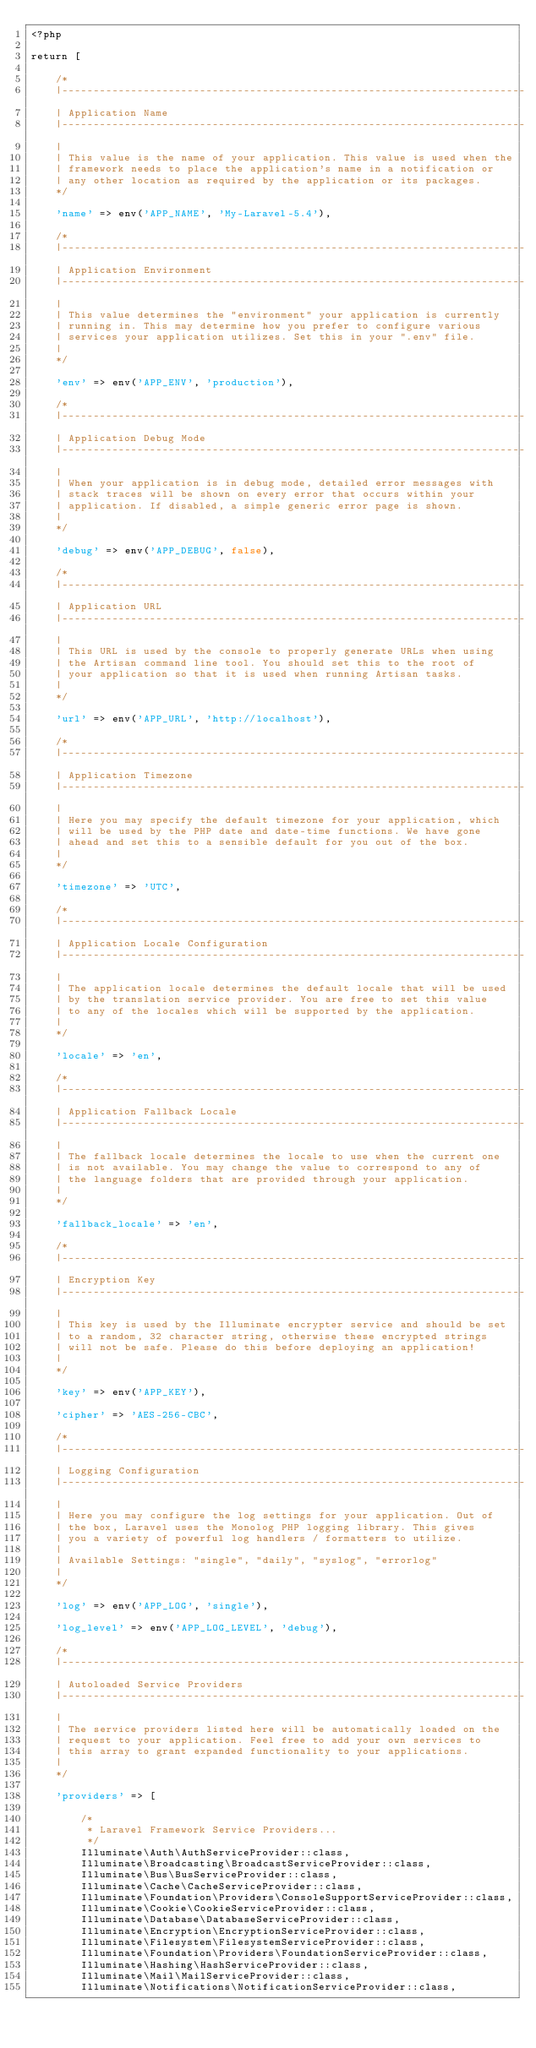Convert code to text. <code><loc_0><loc_0><loc_500><loc_500><_PHP_><?php

return [

    /*
    |--------------------------------------------------------------------------
    | Application Name
    |--------------------------------------------------------------------------
    |
    | This value is the name of your application. This value is used when the
    | framework needs to place the application's name in a notification or
    | any other location as required by the application or its packages.
    */

    'name' => env('APP_NAME', 'My-Laravel-5.4'),

    /*
    |--------------------------------------------------------------------------
    | Application Environment
    |--------------------------------------------------------------------------
    |
    | This value determines the "environment" your application is currently
    | running in. This may determine how you prefer to configure various
    | services your application utilizes. Set this in your ".env" file.
    |
    */

    'env' => env('APP_ENV', 'production'),

    /*
    |--------------------------------------------------------------------------
    | Application Debug Mode
    |--------------------------------------------------------------------------
    |
    | When your application is in debug mode, detailed error messages with
    | stack traces will be shown on every error that occurs within your
    | application. If disabled, a simple generic error page is shown.
    |
    */

    'debug' => env('APP_DEBUG', false),

    /*
    |--------------------------------------------------------------------------
    | Application URL
    |--------------------------------------------------------------------------
    |
    | This URL is used by the console to properly generate URLs when using
    | the Artisan command line tool. You should set this to the root of
    | your application so that it is used when running Artisan tasks.
    |
    */

    'url' => env('APP_URL', 'http://localhost'),

    /*
    |--------------------------------------------------------------------------
    | Application Timezone
    |--------------------------------------------------------------------------
    |
    | Here you may specify the default timezone for your application, which
    | will be used by the PHP date and date-time functions. We have gone
    | ahead and set this to a sensible default for you out of the box.
    |
    */

    'timezone' => 'UTC',

    /*
    |--------------------------------------------------------------------------
    | Application Locale Configuration
    |--------------------------------------------------------------------------
    |
    | The application locale determines the default locale that will be used
    | by the translation service provider. You are free to set this value
    | to any of the locales which will be supported by the application.
    |
    */

    'locale' => 'en',

    /*
    |--------------------------------------------------------------------------
    | Application Fallback Locale
    |--------------------------------------------------------------------------
    |
    | The fallback locale determines the locale to use when the current one
    | is not available. You may change the value to correspond to any of
    | the language folders that are provided through your application.
    |
    */

    'fallback_locale' => 'en',

    /*
    |--------------------------------------------------------------------------
    | Encryption Key
    |--------------------------------------------------------------------------
    |
    | This key is used by the Illuminate encrypter service and should be set
    | to a random, 32 character string, otherwise these encrypted strings
    | will not be safe. Please do this before deploying an application!
    |
    */

    'key' => env('APP_KEY'),

    'cipher' => 'AES-256-CBC',

    /*
    |--------------------------------------------------------------------------
    | Logging Configuration
    |--------------------------------------------------------------------------
    |
    | Here you may configure the log settings for your application. Out of
    | the box, Laravel uses the Monolog PHP logging library. This gives
    | you a variety of powerful log handlers / formatters to utilize.
    |
    | Available Settings: "single", "daily", "syslog", "errorlog"
    |
    */

    'log' => env('APP_LOG', 'single'),

    'log_level' => env('APP_LOG_LEVEL', 'debug'),

    /*
    |--------------------------------------------------------------------------
    | Autoloaded Service Providers
    |--------------------------------------------------------------------------
    |
    | The service providers listed here will be automatically loaded on the
    | request to your application. Feel free to add your own services to
    | this array to grant expanded functionality to your applications.
    |
    */

    'providers' => [

        /*
         * Laravel Framework Service Providers...
         */
        Illuminate\Auth\AuthServiceProvider::class,
        Illuminate\Broadcasting\BroadcastServiceProvider::class,
        Illuminate\Bus\BusServiceProvider::class,
        Illuminate\Cache\CacheServiceProvider::class,
        Illuminate\Foundation\Providers\ConsoleSupportServiceProvider::class,
        Illuminate\Cookie\CookieServiceProvider::class,
        Illuminate\Database\DatabaseServiceProvider::class,
        Illuminate\Encryption\EncryptionServiceProvider::class,
        Illuminate\Filesystem\FilesystemServiceProvider::class,
        Illuminate\Foundation\Providers\FoundationServiceProvider::class,
        Illuminate\Hashing\HashServiceProvider::class,
        Illuminate\Mail\MailServiceProvider::class,
        Illuminate\Notifications\NotificationServiceProvider::class,</code> 